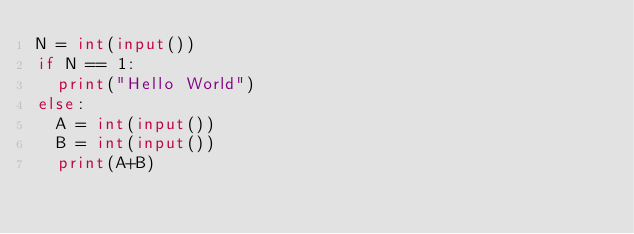<code> <loc_0><loc_0><loc_500><loc_500><_Python_>N = int(input())
if N == 1:
  print("Hello World")
else:
  A = int(input())
  B = int(input())
  print(A+B)
</code> 